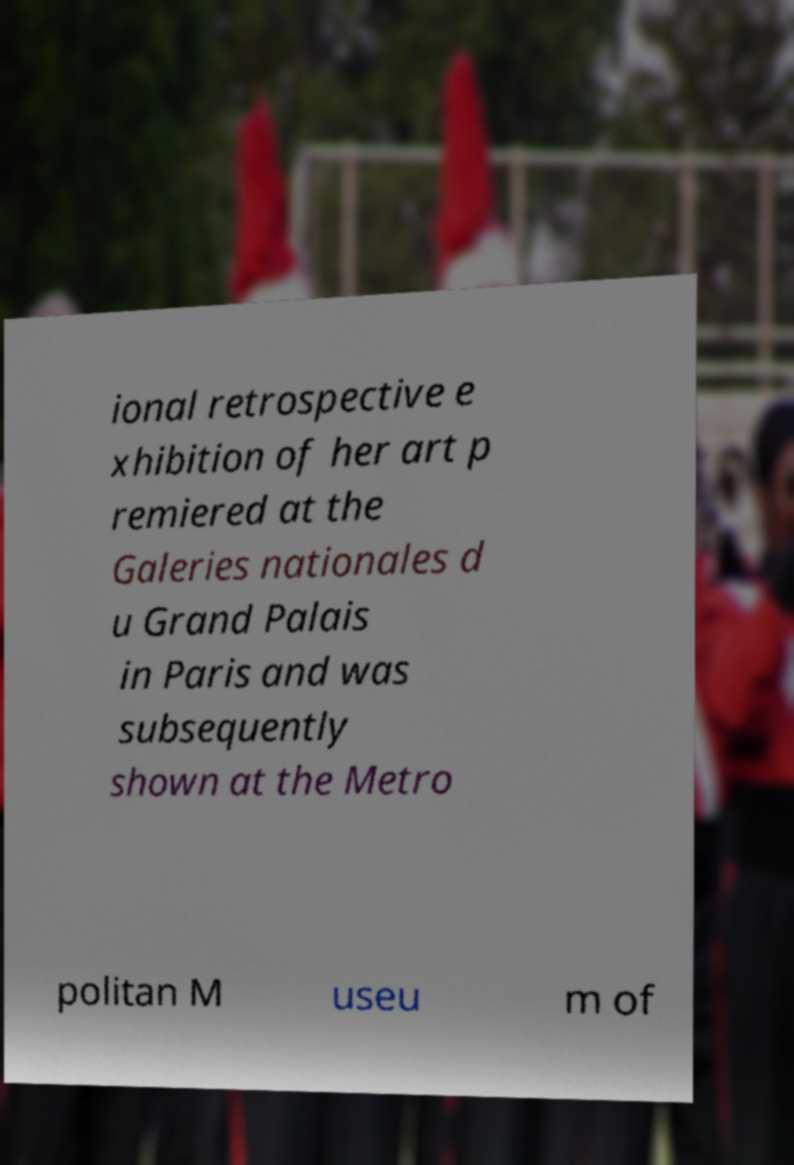For documentation purposes, I need the text within this image transcribed. Could you provide that? ional retrospective e xhibition of her art p remiered at the Galeries nationales d u Grand Palais in Paris and was subsequently shown at the Metro politan M useu m of 